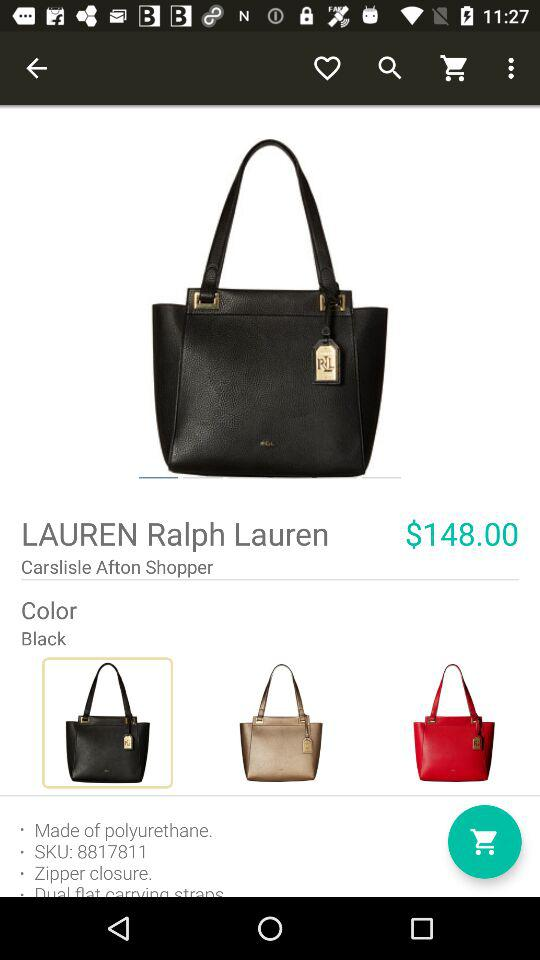How much is the price of the item?
Answer the question using a single word or phrase. $148.00 